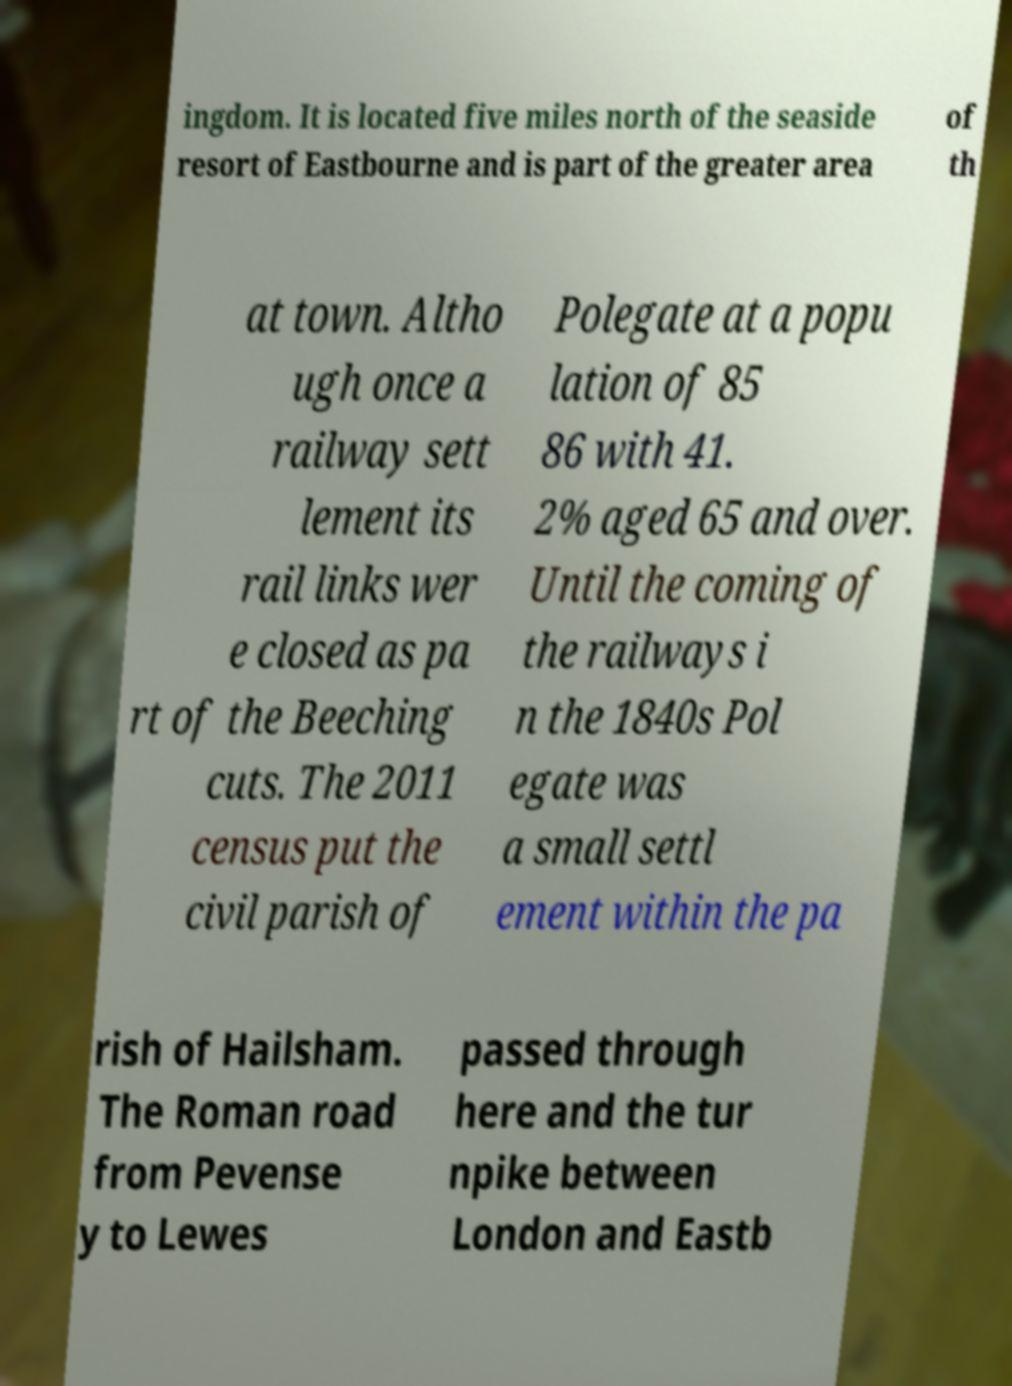There's text embedded in this image that I need extracted. Can you transcribe it verbatim? ingdom. It is located five miles north of the seaside resort of Eastbourne and is part of the greater area of th at town. Altho ugh once a railway sett lement its rail links wer e closed as pa rt of the Beeching cuts. The 2011 census put the civil parish of Polegate at a popu lation of 85 86 with 41. 2% aged 65 and over. Until the coming of the railways i n the 1840s Pol egate was a small settl ement within the pa rish of Hailsham. The Roman road from Pevense y to Lewes passed through here and the tur npike between London and Eastb 